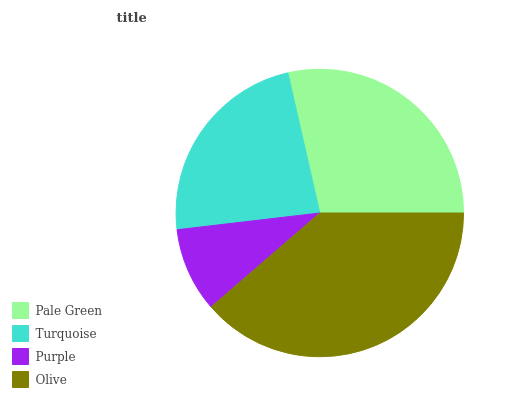Is Purple the minimum?
Answer yes or no. Yes. Is Olive the maximum?
Answer yes or no. Yes. Is Turquoise the minimum?
Answer yes or no. No. Is Turquoise the maximum?
Answer yes or no. No. Is Pale Green greater than Turquoise?
Answer yes or no. Yes. Is Turquoise less than Pale Green?
Answer yes or no. Yes. Is Turquoise greater than Pale Green?
Answer yes or no. No. Is Pale Green less than Turquoise?
Answer yes or no. No. Is Pale Green the high median?
Answer yes or no. Yes. Is Turquoise the low median?
Answer yes or no. Yes. Is Turquoise the high median?
Answer yes or no. No. Is Olive the low median?
Answer yes or no. No. 